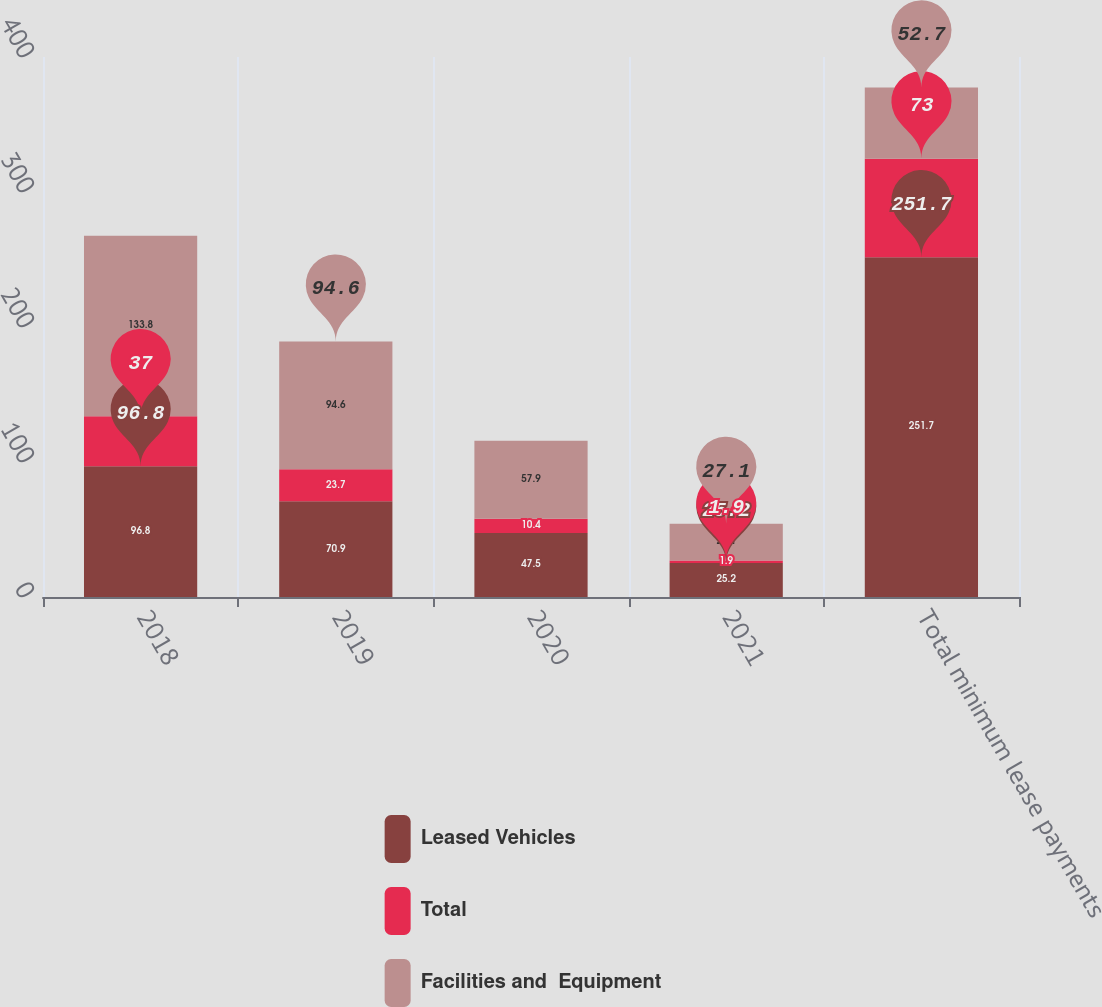<chart> <loc_0><loc_0><loc_500><loc_500><stacked_bar_chart><ecel><fcel>2018<fcel>2019<fcel>2020<fcel>2021<fcel>Total minimum lease payments<nl><fcel>Leased Vehicles<fcel>96.8<fcel>70.9<fcel>47.5<fcel>25.2<fcel>251.7<nl><fcel>Total<fcel>37<fcel>23.7<fcel>10.4<fcel>1.9<fcel>73<nl><fcel>Facilities and  Equipment<fcel>133.8<fcel>94.6<fcel>57.9<fcel>27.1<fcel>52.7<nl></chart> 